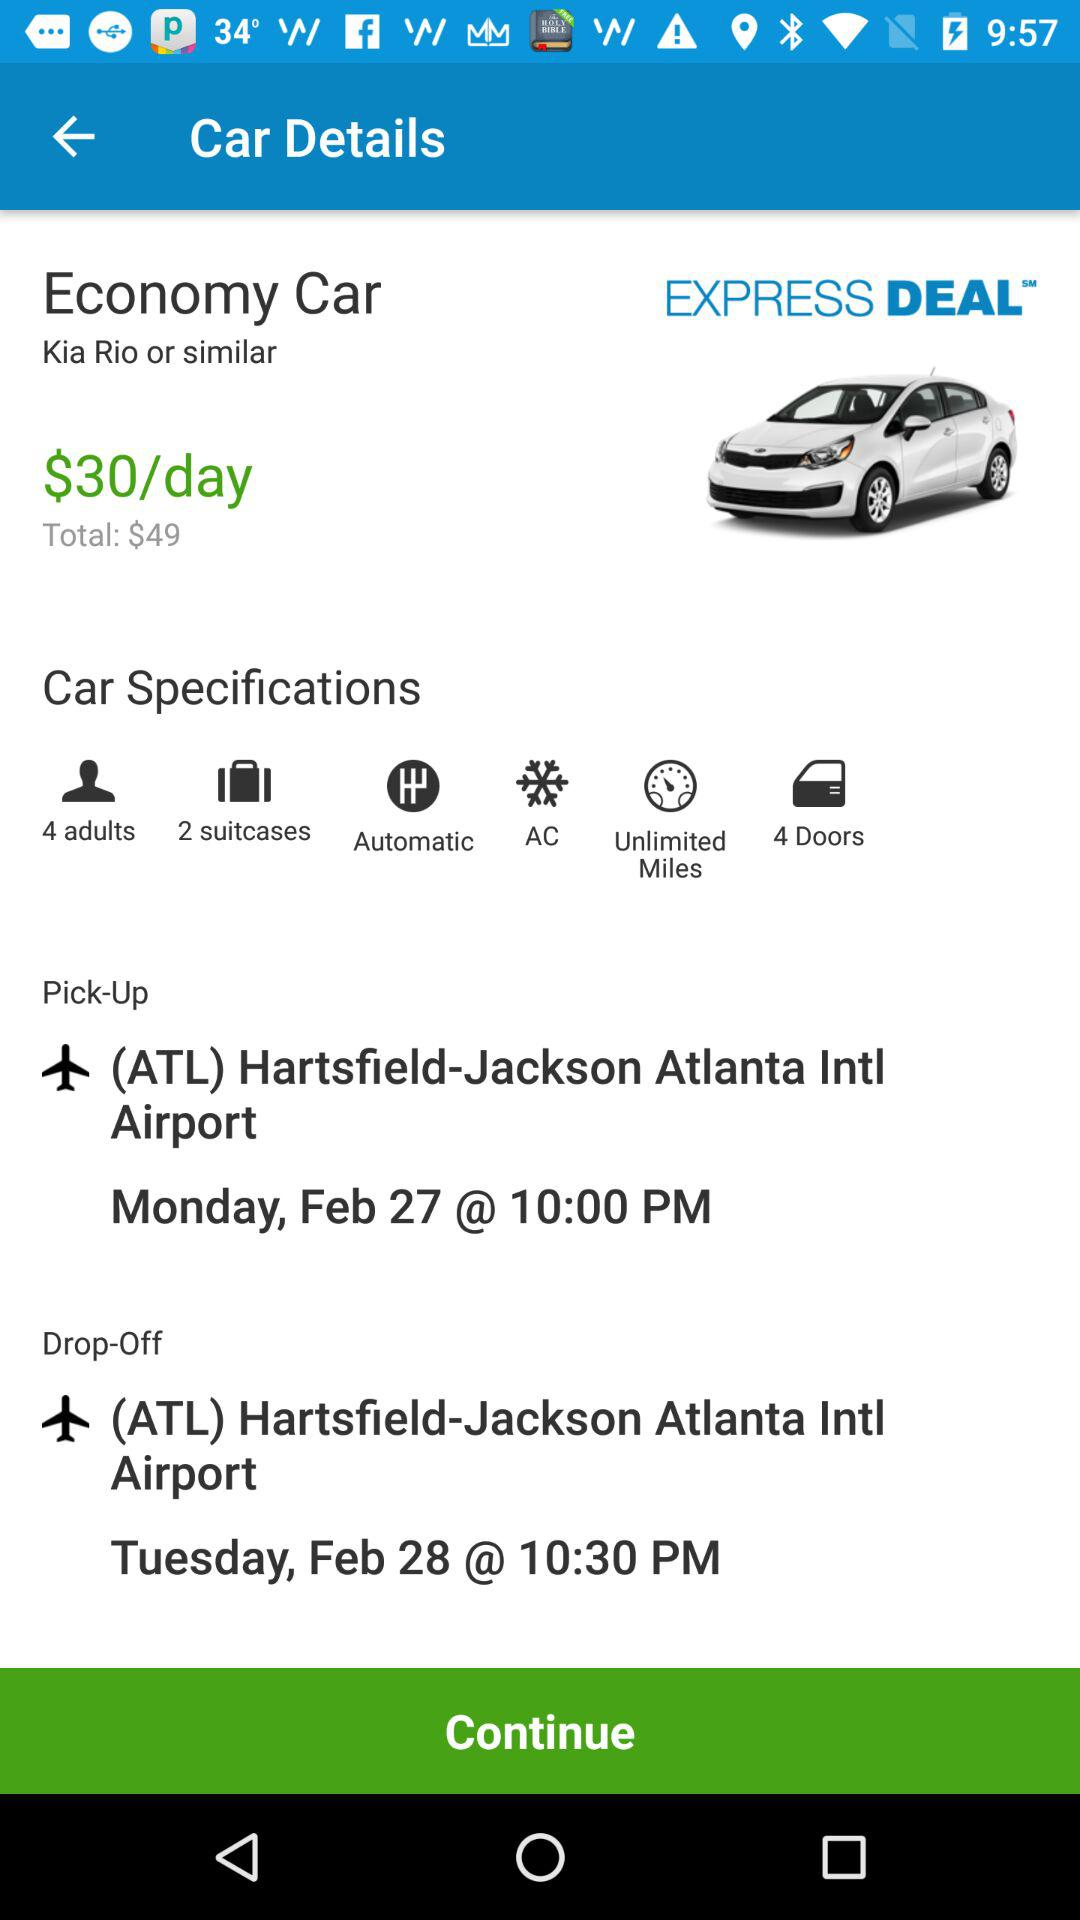What are the car specifications? The car specifications are "4 adults", "2 suitcases", "Automatic", "AC", "Unlimited Miles" and "4 Doors". 